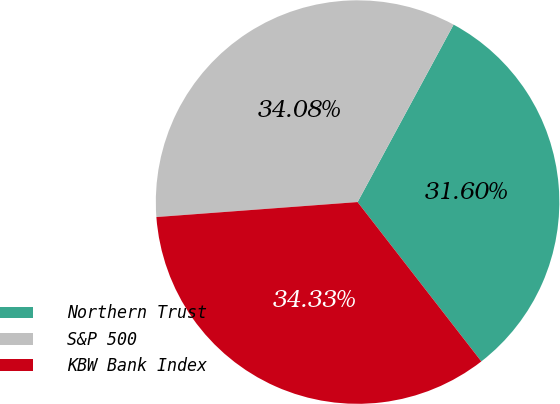Convert chart. <chart><loc_0><loc_0><loc_500><loc_500><pie_chart><fcel>Northern Trust<fcel>S&P 500<fcel>KBW Bank Index<nl><fcel>31.6%<fcel>34.08%<fcel>34.33%<nl></chart> 